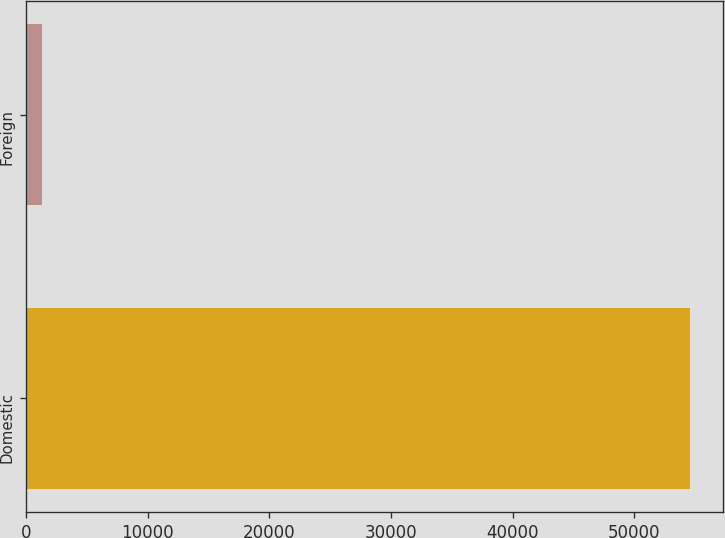Convert chart to OTSL. <chart><loc_0><loc_0><loc_500><loc_500><bar_chart><fcel>Domestic<fcel>Foreign<nl><fcel>54542<fcel>1319<nl></chart> 